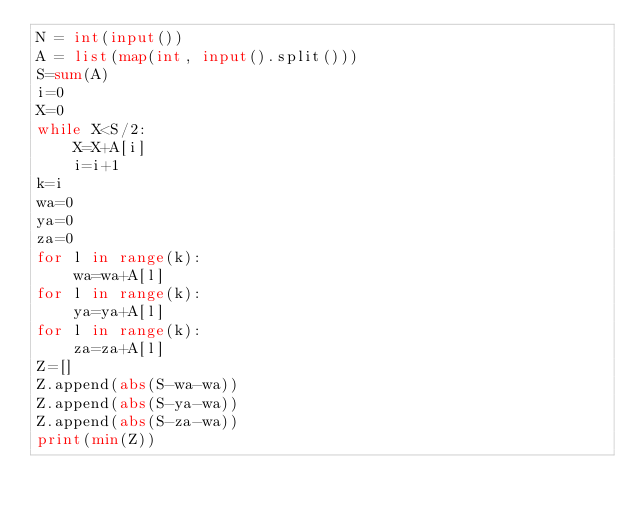<code> <loc_0><loc_0><loc_500><loc_500><_Python_>N = int(input())
A = list(map(int, input().split()))
S=sum(A)
i=0
X=0
while X<S/2:
    X=X+A[i]
    i=i+1
k=i
wa=0
ya=0
za=0
for l in range(k):
    wa=wa+A[l]
for l in range(k):
    ya=ya+A[l]
for l in range(k):
    za=za+A[l]
Z=[]
Z.append(abs(S-wa-wa))
Z.append(abs(S-ya-wa))
Z.append(abs(S-za-wa))
print(min(Z))
</code> 